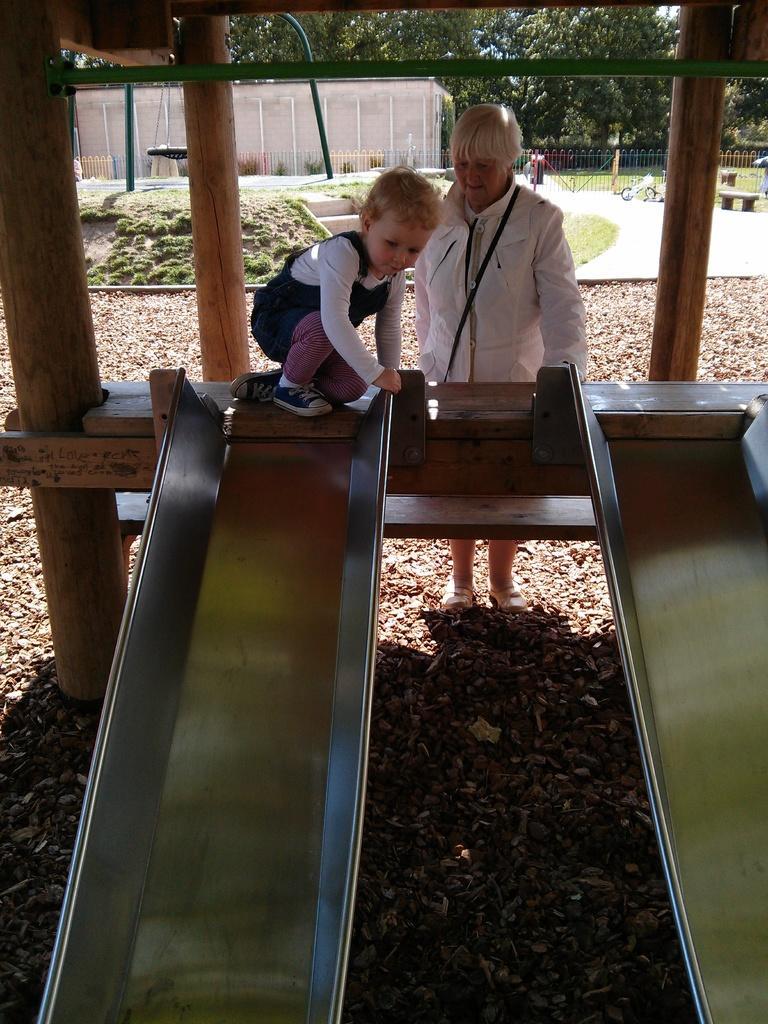Can you describe this image briefly? In this image there is a boy sitting on the wooden platform. In front of him there are slopes. Behind him there is a person standing. At the bottom of the image there are stones. There are pillars. In the background of the image there is a metal fence, light poles, trees. There is a building and a few other objects. 